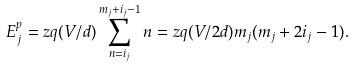<formula> <loc_0><loc_0><loc_500><loc_500>E ^ { p } _ { j } = z q ( V / d ) \sum _ { n = i _ { j } } ^ { m _ { j } + i _ { j } - 1 } n = z q ( V / 2 d ) m _ { j } ( m _ { j } + 2 i _ { j } - 1 ) .</formula> 